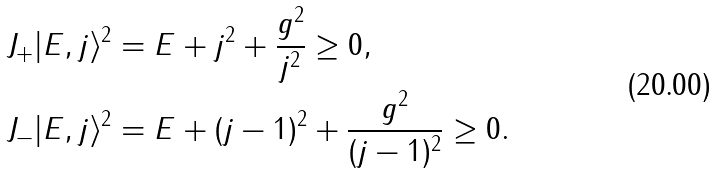Convert formula to latex. <formula><loc_0><loc_0><loc_500><loc_500>\| J _ { + } | E , j \rangle \| ^ { 2 } & = E + j ^ { 2 } + \frac { g ^ { 2 } } { j ^ { 2 } } \geq 0 , \\ \| J _ { - } | E , j \rangle \| ^ { 2 } & = E + ( j - 1 ) ^ { 2 } + \frac { g ^ { 2 } } { ( j - 1 ) ^ { 2 } } \geq 0 .</formula> 